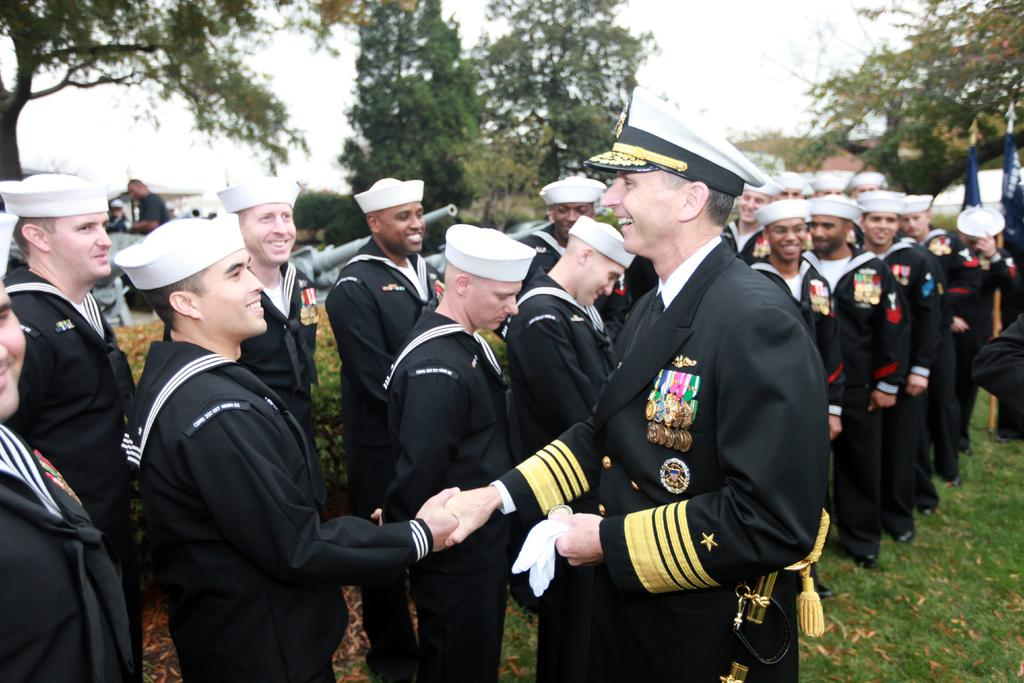What type of vegetation can be seen in the image? There is grass in the image. What else is present in the image besides the grass? There are people standing in the image. What can be seen in the background of the image? There are trees in the background of the image. What is visible above the people and trees in the image? The sky is visible in the image. Where is the throne located in the image? There is no throne present in the image. Can you describe the swing that is hanging from the tree in the image? There is no swing present in the image; only grass, people, trees, and the sky are visible. 